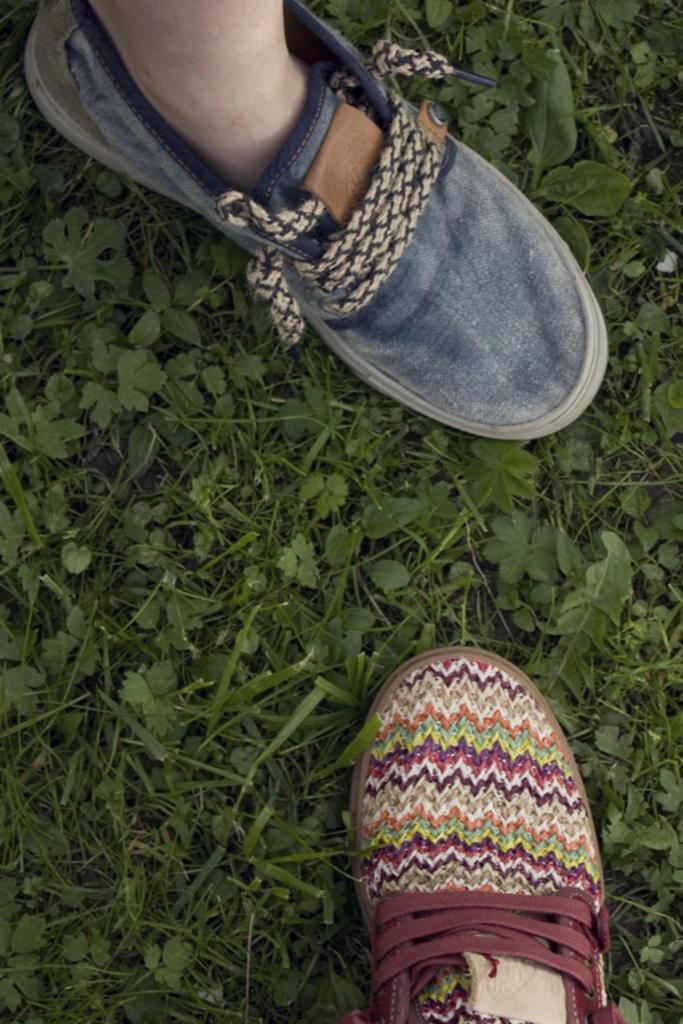Describe this image in one or two sentences. In this image we can see a person's foot and a shoe placed on the ground. 